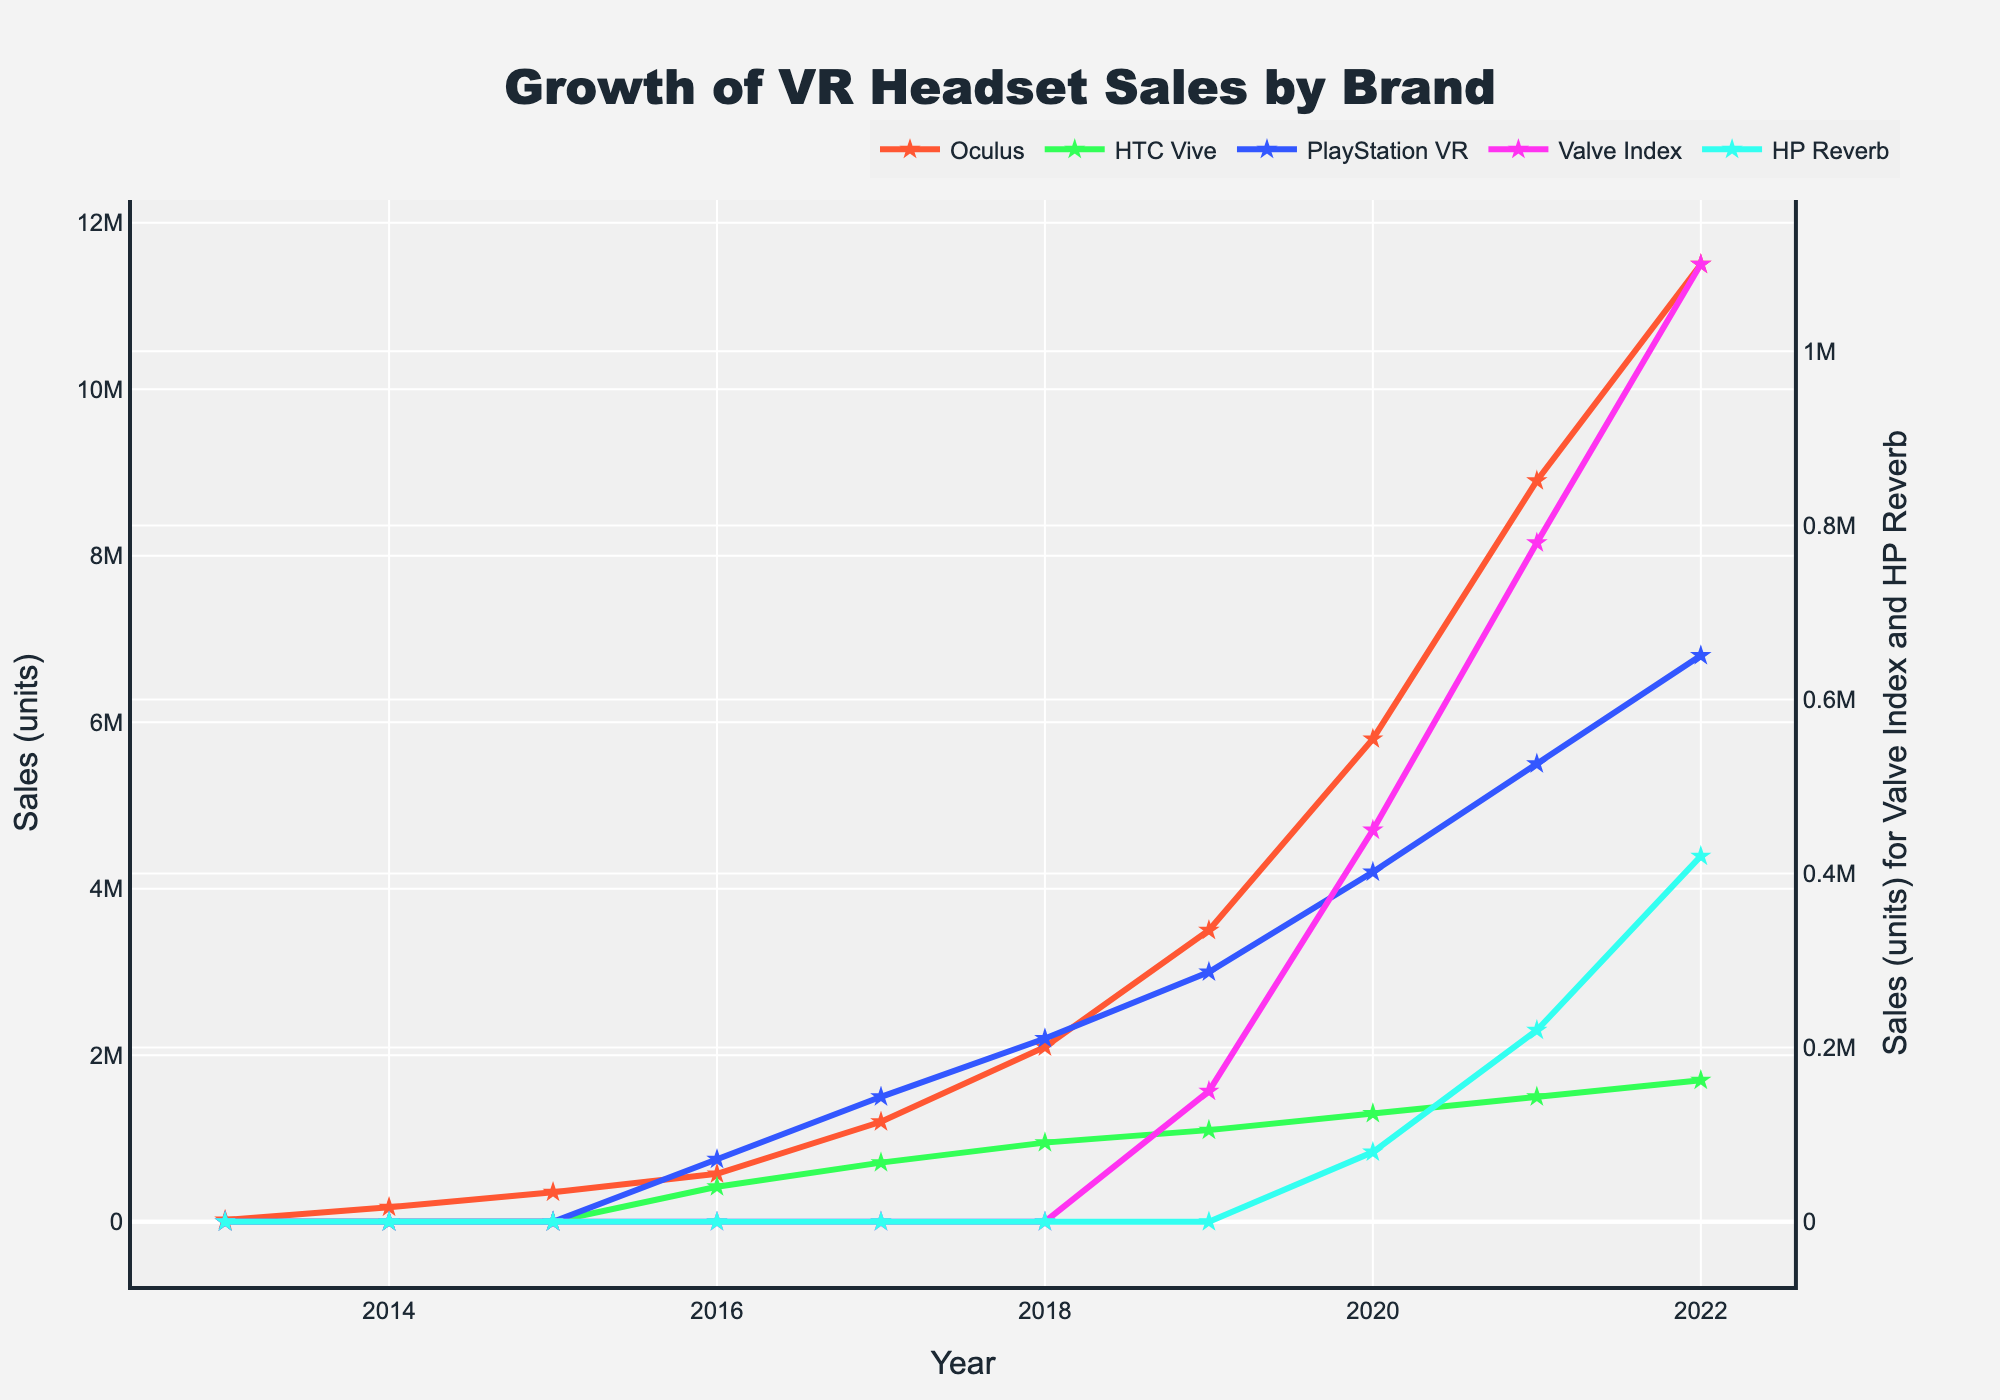What's the trend of Oculus sales over the decade? The sales of Oculus show a consistent upward trend throughout the decade, starting from 20,000 units in 2013 and reaching 11,500,000 units in 2022.
Answer: Upward trend Which brand had the highest sales in 2018? In 2018, PlayStation VR had the highest sales with 2,200,000 units, indicated by the highest point among the lines.
Answer: PlayStation VR What is the difference in sales between Valve Index and HP Reverb in 2021? In 2021, Valve Index sold 780,000 units and HP Reverb sold 220,000 units. The difference is 780,000 - 220,000 = 560,000 units.
Answer: 560,000 units How do the sales of HTC Vive compare to Oculus in 2016? In 2016, HTC Vive had 420,000 units sold, while Oculus sold 575,000 units. Therefore, Oculus had higher sales than HTC Vive in 2016.
Answer: Oculus had higher sales Which year did PlayStation VR surpass 5 million units in sales? PlayStation VR surpassed 5 million units in sales in 2021, reaching 5,500,000 units.
Answer: 2021 What is the cumulative sales of VR headsets for the year 2020? For 2020, sum the sales of each brand: 5,800,000 (Oculus) + 1,300,000 (HTC Vive) + 4,200,000 (PlayStation VR) + 450,000 (Valve Index) + 80,000 (HP Reverb) = 11,830,000 units.
Answer: 11,830,000 units Identify the year when HP Reverb sales were introduced and the number of units sold. HP Reverb sales data first appears in 2020 with 80,000 units sold, as indicated by their first data point on the line chart.
Answer: 2020, 80,000 units Which brands had no sales data reported in 2015? In 2015, only Oculus has sales data reported, meaning HTC Vive, PlayStation VR, Valve Index, and HP Reverb had no data reported.
Answer: HTC Vive, PlayStation VR, Valve Index, HP Reverb What is the average sales for HTC Vive from 2016 to 2022? Sum the HTC Vive sales from 2016 to 2022, and divide by the number of years: (420,000 + 710,000 + 950,000 + 1,100,000 + 1,300,000 + 1,500,000 + 1,700,000) / 7 = 1,097,143 units.
Answer: 1,097,143 units Compare the sales growth between Oculus and PlayStation VR from 2016 to 2022. Oculus grew from 575,000 units in 2016 to 11,500,000 units in 2022, an increase of 10,925,000 units. PlayStation VR grew from 750,000 units in 2016 to 6,800,000 units in 2022, an increase of 6,050,000 units. Oculus had higher growth.
Answer: Oculus had higher growth 